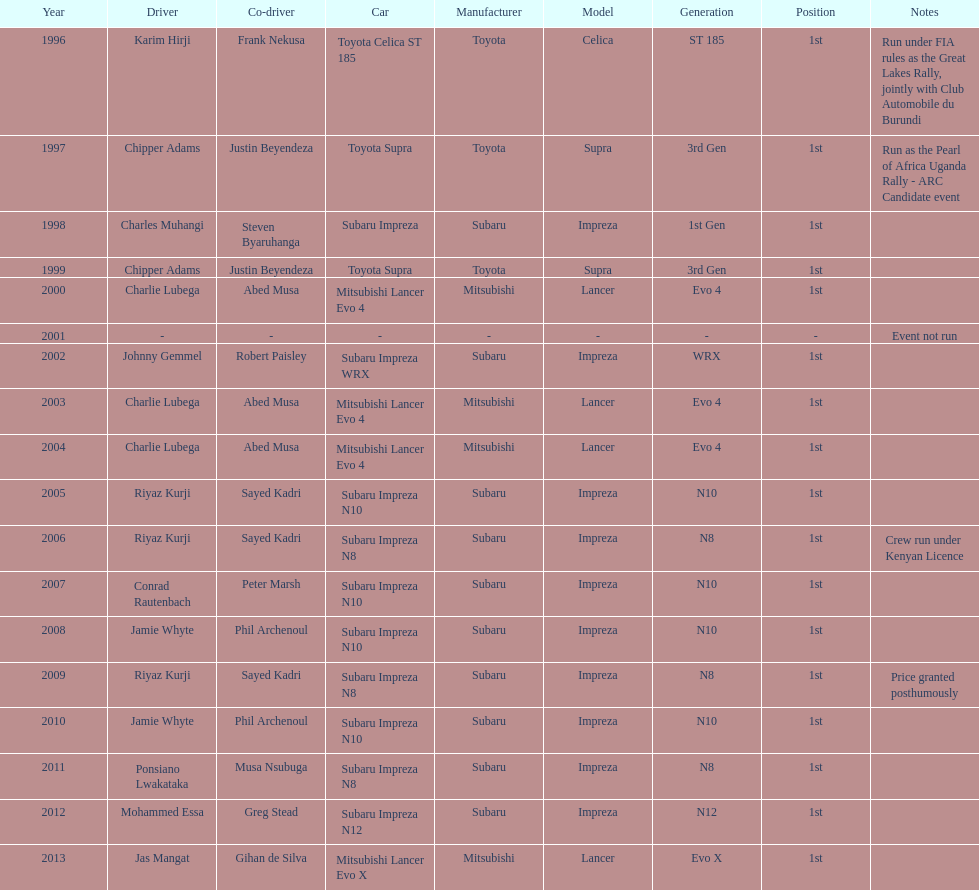What is the total number of times that the winning driver was driving a toyota supra? 2. 